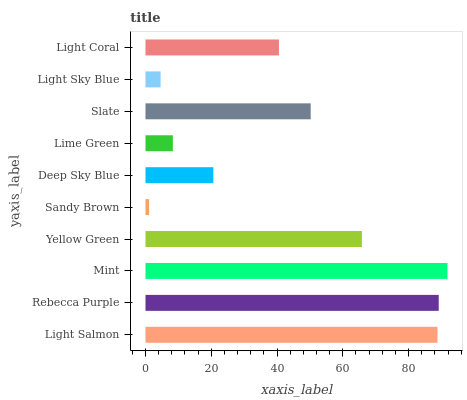Is Sandy Brown the minimum?
Answer yes or no. Yes. Is Mint the maximum?
Answer yes or no. Yes. Is Rebecca Purple the minimum?
Answer yes or no. No. Is Rebecca Purple the maximum?
Answer yes or no. No. Is Rebecca Purple greater than Light Salmon?
Answer yes or no. Yes. Is Light Salmon less than Rebecca Purple?
Answer yes or no. Yes. Is Light Salmon greater than Rebecca Purple?
Answer yes or no. No. Is Rebecca Purple less than Light Salmon?
Answer yes or no. No. Is Slate the high median?
Answer yes or no. Yes. Is Light Coral the low median?
Answer yes or no. Yes. Is Rebecca Purple the high median?
Answer yes or no. No. Is Light Salmon the low median?
Answer yes or no. No. 